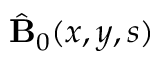Convert formula to latex. <formula><loc_0><loc_0><loc_500><loc_500>\hat { B } _ { 0 } ( x , y , s )</formula> 